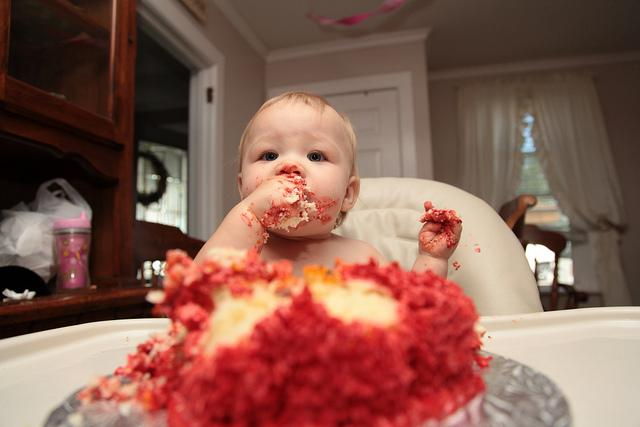What's the baby done to get so messy?

Choices:
A) found dirt
B) opened jar
C) ate food
D) painted picture ate food 